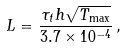<formula> <loc_0><loc_0><loc_500><loc_500>L = \frac { \tau _ { t } h \sqrt { T _ { \max } } } { 3 . 7 \times 1 0 ^ { - 4 } } \, ,</formula> 